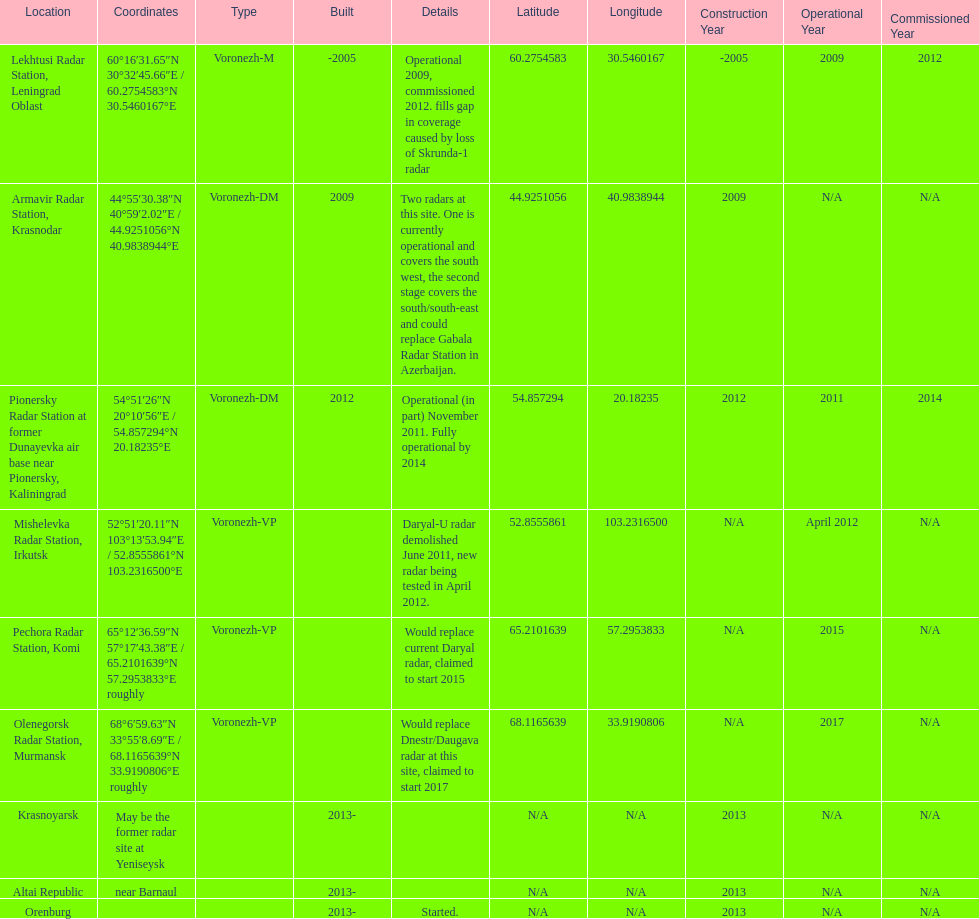What is the only location with a coordination of 60°16&#8242;31.65&#8243;n 30°32&#8242;45.66&#8243;e / 60.2754583°n 30.5460167°e? Lekhtusi Radar Station, Leningrad Oblast. 